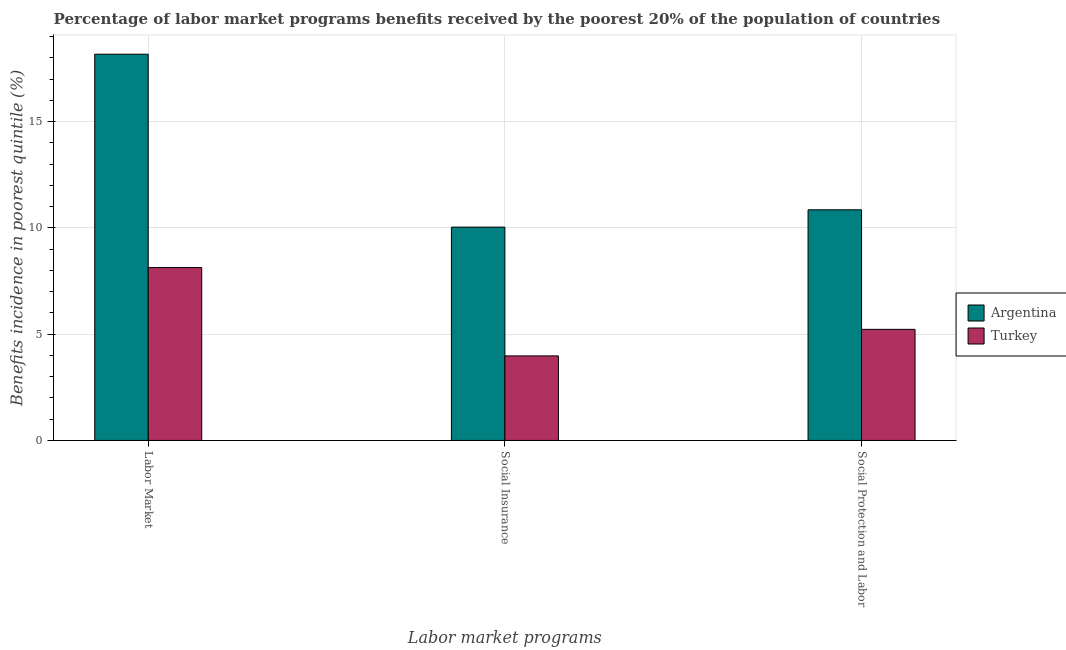How many different coloured bars are there?
Provide a short and direct response. 2. Are the number of bars per tick equal to the number of legend labels?
Provide a short and direct response. Yes. How many bars are there on the 3rd tick from the left?
Offer a terse response. 2. How many bars are there on the 2nd tick from the right?
Offer a very short reply. 2. What is the label of the 3rd group of bars from the left?
Offer a very short reply. Social Protection and Labor. What is the percentage of benefits received due to social insurance programs in Turkey?
Give a very brief answer. 3.98. Across all countries, what is the maximum percentage of benefits received due to labor market programs?
Offer a terse response. 18.17. Across all countries, what is the minimum percentage of benefits received due to social insurance programs?
Offer a very short reply. 3.98. In which country was the percentage of benefits received due to social protection programs maximum?
Ensure brevity in your answer.  Argentina. What is the total percentage of benefits received due to social insurance programs in the graph?
Your answer should be very brief. 14.01. What is the difference between the percentage of benefits received due to labor market programs in Argentina and that in Turkey?
Provide a short and direct response. 10.04. What is the difference between the percentage of benefits received due to social protection programs in Turkey and the percentage of benefits received due to labor market programs in Argentina?
Offer a very short reply. -12.95. What is the average percentage of benefits received due to social insurance programs per country?
Ensure brevity in your answer.  7.01. What is the difference between the percentage of benefits received due to social protection programs and percentage of benefits received due to labor market programs in Turkey?
Make the answer very short. -2.91. What is the ratio of the percentage of benefits received due to social protection programs in Turkey to that in Argentina?
Your response must be concise. 0.48. What is the difference between the highest and the second highest percentage of benefits received due to social insurance programs?
Ensure brevity in your answer.  6.06. What is the difference between the highest and the lowest percentage of benefits received due to social protection programs?
Provide a short and direct response. 5.62. In how many countries, is the percentage of benefits received due to social insurance programs greater than the average percentage of benefits received due to social insurance programs taken over all countries?
Ensure brevity in your answer.  1. What does the 1st bar from the left in Labor Market represents?
Offer a very short reply. Argentina. What does the 2nd bar from the right in Social Insurance represents?
Make the answer very short. Argentina. How many countries are there in the graph?
Ensure brevity in your answer.  2. Does the graph contain any zero values?
Offer a very short reply. No. Where does the legend appear in the graph?
Offer a terse response. Center right. What is the title of the graph?
Provide a succinct answer. Percentage of labor market programs benefits received by the poorest 20% of the population of countries. What is the label or title of the X-axis?
Your answer should be compact. Labor market programs. What is the label or title of the Y-axis?
Offer a terse response. Benefits incidence in poorest quintile (%). What is the Benefits incidence in poorest quintile (%) in Argentina in Labor Market?
Your answer should be compact. 18.17. What is the Benefits incidence in poorest quintile (%) of Turkey in Labor Market?
Provide a succinct answer. 8.13. What is the Benefits incidence in poorest quintile (%) in Argentina in Social Insurance?
Make the answer very short. 10.04. What is the Benefits incidence in poorest quintile (%) in Turkey in Social Insurance?
Provide a short and direct response. 3.98. What is the Benefits incidence in poorest quintile (%) of Argentina in Social Protection and Labor?
Your answer should be compact. 10.85. What is the Benefits incidence in poorest quintile (%) of Turkey in Social Protection and Labor?
Your answer should be compact. 5.23. Across all Labor market programs, what is the maximum Benefits incidence in poorest quintile (%) of Argentina?
Your answer should be compact. 18.17. Across all Labor market programs, what is the maximum Benefits incidence in poorest quintile (%) of Turkey?
Provide a succinct answer. 8.13. Across all Labor market programs, what is the minimum Benefits incidence in poorest quintile (%) of Argentina?
Provide a short and direct response. 10.04. Across all Labor market programs, what is the minimum Benefits incidence in poorest quintile (%) in Turkey?
Offer a terse response. 3.98. What is the total Benefits incidence in poorest quintile (%) of Argentina in the graph?
Offer a terse response. 39.06. What is the total Benefits incidence in poorest quintile (%) of Turkey in the graph?
Your answer should be very brief. 17.34. What is the difference between the Benefits incidence in poorest quintile (%) in Argentina in Labor Market and that in Social Insurance?
Offer a terse response. 8.14. What is the difference between the Benefits incidence in poorest quintile (%) of Turkey in Labor Market and that in Social Insurance?
Your answer should be compact. 4.16. What is the difference between the Benefits incidence in poorest quintile (%) in Argentina in Labor Market and that in Social Protection and Labor?
Offer a terse response. 7.32. What is the difference between the Benefits incidence in poorest quintile (%) in Turkey in Labor Market and that in Social Protection and Labor?
Your answer should be compact. 2.91. What is the difference between the Benefits incidence in poorest quintile (%) in Argentina in Social Insurance and that in Social Protection and Labor?
Offer a terse response. -0.81. What is the difference between the Benefits incidence in poorest quintile (%) of Turkey in Social Insurance and that in Social Protection and Labor?
Your answer should be very brief. -1.25. What is the difference between the Benefits incidence in poorest quintile (%) of Argentina in Labor Market and the Benefits incidence in poorest quintile (%) of Turkey in Social Insurance?
Offer a terse response. 14.2. What is the difference between the Benefits incidence in poorest quintile (%) in Argentina in Labor Market and the Benefits incidence in poorest quintile (%) in Turkey in Social Protection and Labor?
Offer a very short reply. 12.95. What is the difference between the Benefits incidence in poorest quintile (%) of Argentina in Social Insurance and the Benefits incidence in poorest quintile (%) of Turkey in Social Protection and Labor?
Your response must be concise. 4.81. What is the average Benefits incidence in poorest quintile (%) of Argentina per Labor market programs?
Give a very brief answer. 13.02. What is the average Benefits incidence in poorest quintile (%) of Turkey per Labor market programs?
Keep it short and to the point. 5.78. What is the difference between the Benefits incidence in poorest quintile (%) in Argentina and Benefits incidence in poorest quintile (%) in Turkey in Labor Market?
Offer a terse response. 10.04. What is the difference between the Benefits incidence in poorest quintile (%) of Argentina and Benefits incidence in poorest quintile (%) of Turkey in Social Insurance?
Give a very brief answer. 6.06. What is the difference between the Benefits incidence in poorest quintile (%) in Argentina and Benefits incidence in poorest quintile (%) in Turkey in Social Protection and Labor?
Your answer should be compact. 5.62. What is the ratio of the Benefits incidence in poorest quintile (%) in Argentina in Labor Market to that in Social Insurance?
Keep it short and to the point. 1.81. What is the ratio of the Benefits incidence in poorest quintile (%) in Turkey in Labor Market to that in Social Insurance?
Your answer should be very brief. 2.04. What is the ratio of the Benefits incidence in poorest quintile (%) in Argentina in Labor Market to that in Social Protection and Labor?
Provide a succinct answer. 1.67. What is the ratio of the Benefits incidence in poorest quintile (%) in Turkey in Labor Market to that in Social Protection and Labor?
Your response must be concise. 1.56. What is the ratio of the Benefits incidence in poorest quintile (%) of Argentina in Social Insurance to that in Social Protection and Labor?
Keep it short and to the point. 0.93. What is the ratio of the Benefits incidence in poorest quintile (%) in Turkey in Social Insurance to that in Social Protection and Labor?
Give a very brief answer. 0.76. What is the difference between the highest and the second highest Benefits incidence in poorest quintile (%) of Argentina?
Ensure brevity in your answer.  7.32. What is the difference between the highest and the second highest Benefits incidence in poorest quintile (%) of Turkey?
Make the answer very short. 2.91. What is the difference between the highest and the lowest Benefits incidence in poorest quintile (%) of Argentina?
Your answer should be very brief. 8.14. What is the difference between the highest and the lowest Benefits incidence in poorest quintile (%) in Turkey?
Keep it short and to the point. 4.16. 